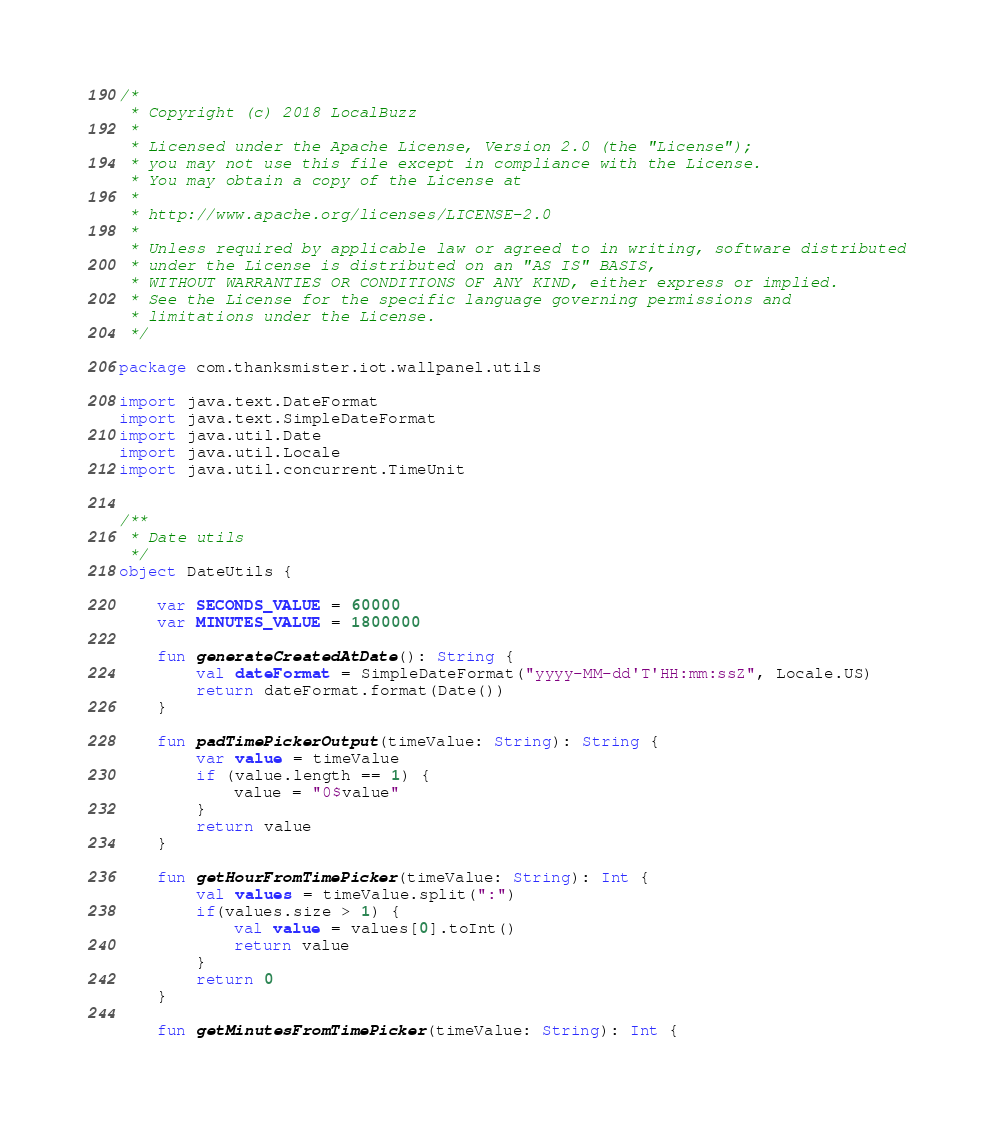<code> <loc_0><loc_0><loc_500><loc_500><_Kotlin_>/*
 * Copyright (c) 2018 LocalBuzz
 *
 * Licensed under the Apache License, Version 2.0 (the "License");
 * you may not use this file except in compliance with the License.
 * You may obtain a copy of the License at
 *
 * http://www.apache.org/licenses/LICENSE-2.0
 *
 * Unless required by applicable law or agreed to in writing, software distributed
 * under the License is distributed on an "AS IS" BASIS,
 * WITHOUT WARRANTIES OR CONDITIONS OF ANY KIND, either express or implied.
 * See the License for the specific language governing permissions and
 * limitations under the License.
 */

package com.thanksmister.iot.wallpanel.utils

import java.text.DateFormat
import java.text.SimpleDateFormat
import java.util.Date
import java.util.Locale
import java.util.concurrent.TimeUnit


/**
 * Date utils
 */
object DateUtils {

    var SECONDS_VALUE = 60000
    var MINUTES_VALUE = 1800000

    fun generateCreatedAtDate(): String {
        val dateFormat = SimpleDateFormat("yyyy-MM-dd'T'HH:mm:ssZ", Locale.US)
        return dateFormat.format(Date())
    }

    fun padTimePickerOutput(timeValue: String): String {
        var value = timeValue
        if (value.length == 1) {
            value = "0$value"
        }
        return value
    }

    fun getHourFromTimePicker(timeValue: String): Int {
        val values = timeValue.split(":")
        if(values.size > 1) {
            val value = values[0].toInt()
            return value
        }
        return 0
    }

    fun getMinutesFromTimePicker(timeValue: String): Int {</code> 